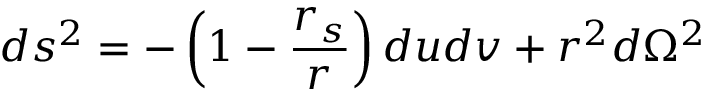<formula> <loc_0><loc_0><loc_500><loc_500>d s ^ { 2 } = - \left ( 1 - \frac { r _ { s } } { r } \right ) d u d v + r ^ { 2 } d \Omega ^ { 2 }</formula> 